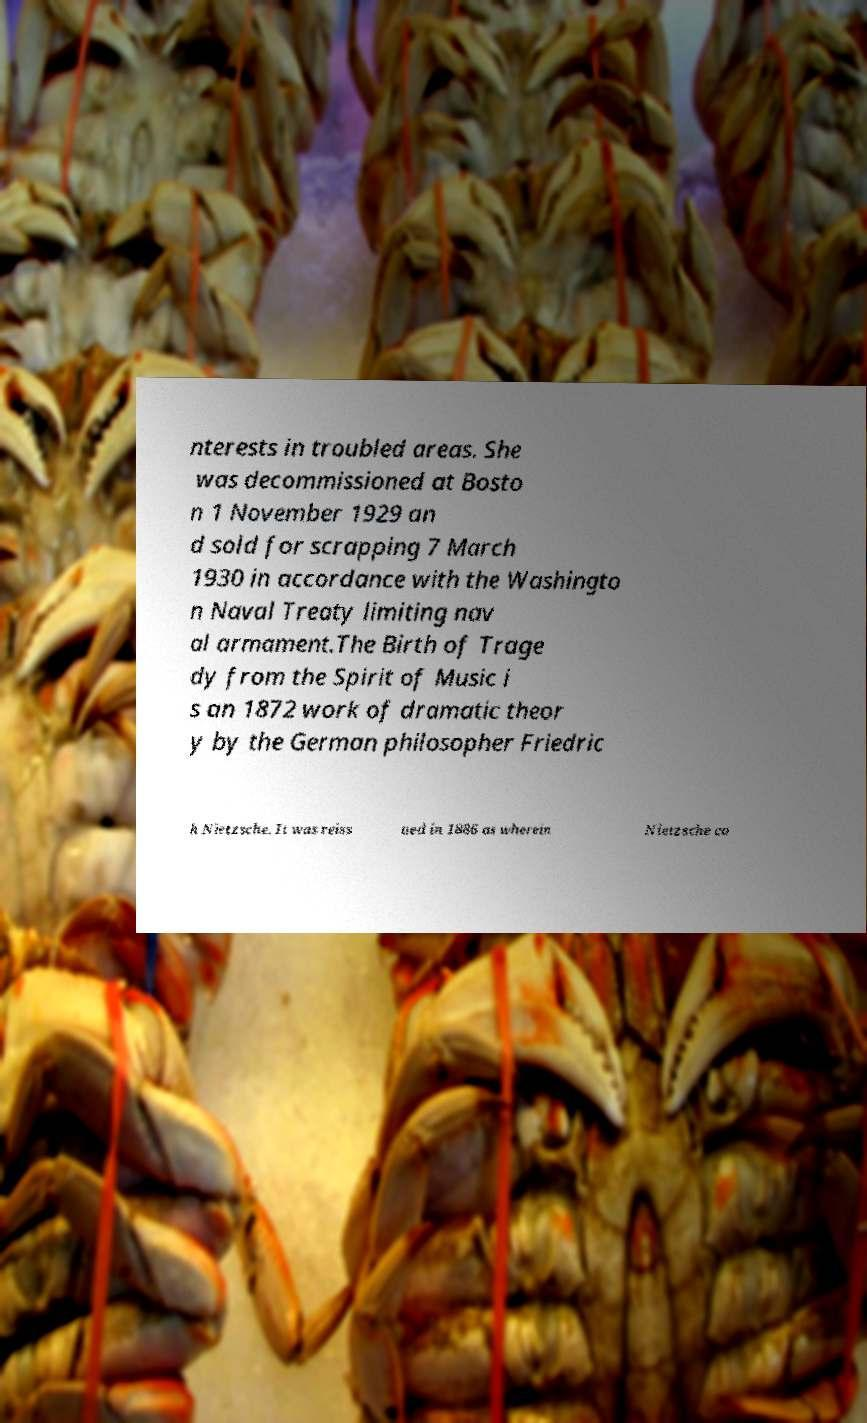Could you extract and type out the text from this image? nterests in troubled areas. She was decommissioned at Bosto n 1 November 1929 an d sold for scrapping 7 March 1930 in accordance with the Washingto n Naval Treaty limiting nav al armament.The Birth of Trage dy from the Spirit of Music i s an 1872 work of dramatic theor y by the German philosopher Friedric h Nietzsche. It was reiss ued in 1886 as wherein Nietzsche co 